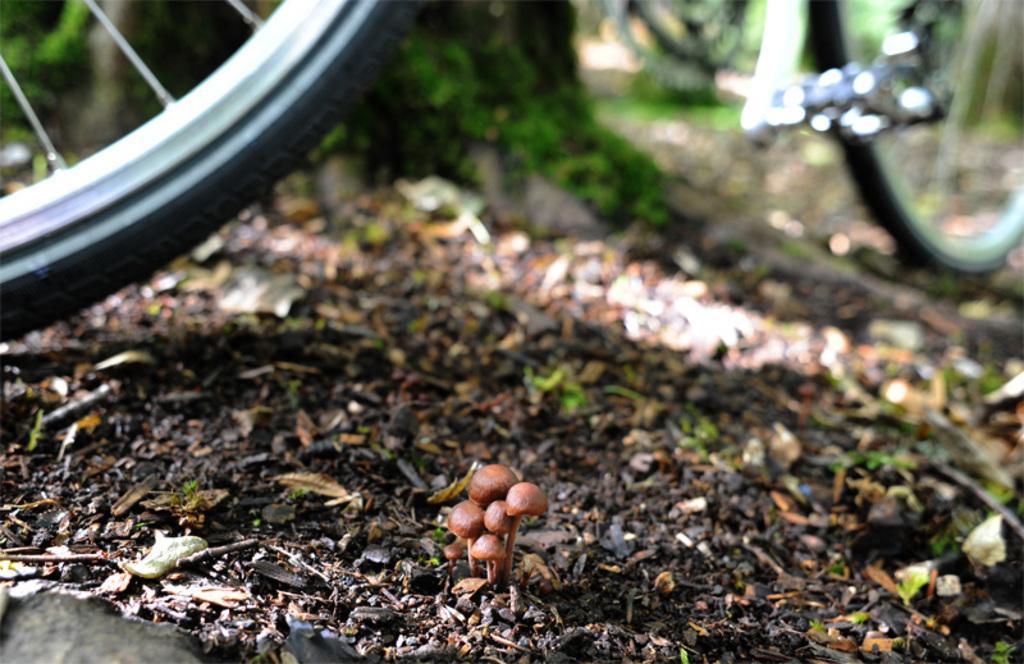Describe this image in one or two sentences. Background portion of the picture is blur. In this picture we can see the partial part of a bicycle. At the bottom portion of the picture we can see the ground, dried leaves and tiny mushrooms. 